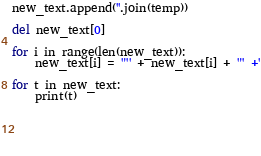<code> <loc_0><loc_0><loc_500><loc_500><_Python_>new_text.append(''.join(temp))

del new_text[0]

for i in range(len(new_text)):
    new_text[i] = '"' + new_text[i] + '" +'
    
for t in new_text:
    print(t)
    
    
       
        
        </code> 